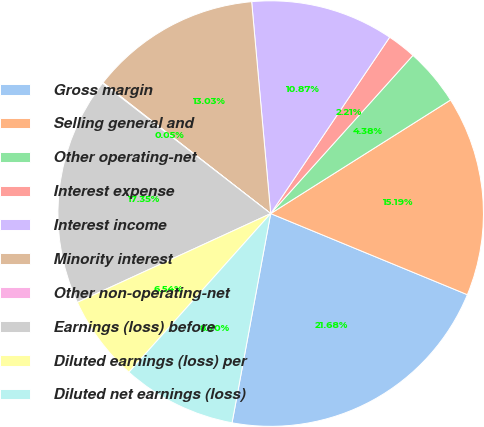<chart> <loc_0><loc_0><loc_500><loc_500><pie_chart><fcel>Gross margin<fcel>Selling general and<fcel>Other operating-net<fcel>Interest expense<fcel>Interest income<fcel>Minority interest<fcel>Other non-operating-net<fcel>Earnings (loss) before<fcel>Diluted earnings (loss) per<fcel>Diluted net earnings (loss)<nl><fcel>21.68%<fcel>15.19%<fcel>4.38%<fcel>2.21%<fcel>10.87%<fcel>13.03%<fcel>0.05%<fcel>17.35%<fcel>6.54%<fcel>8.7%<nl></chart> 